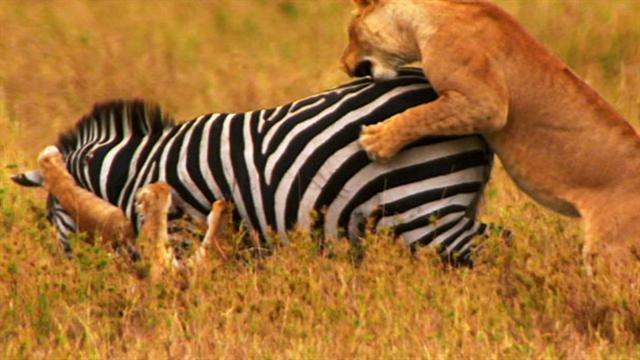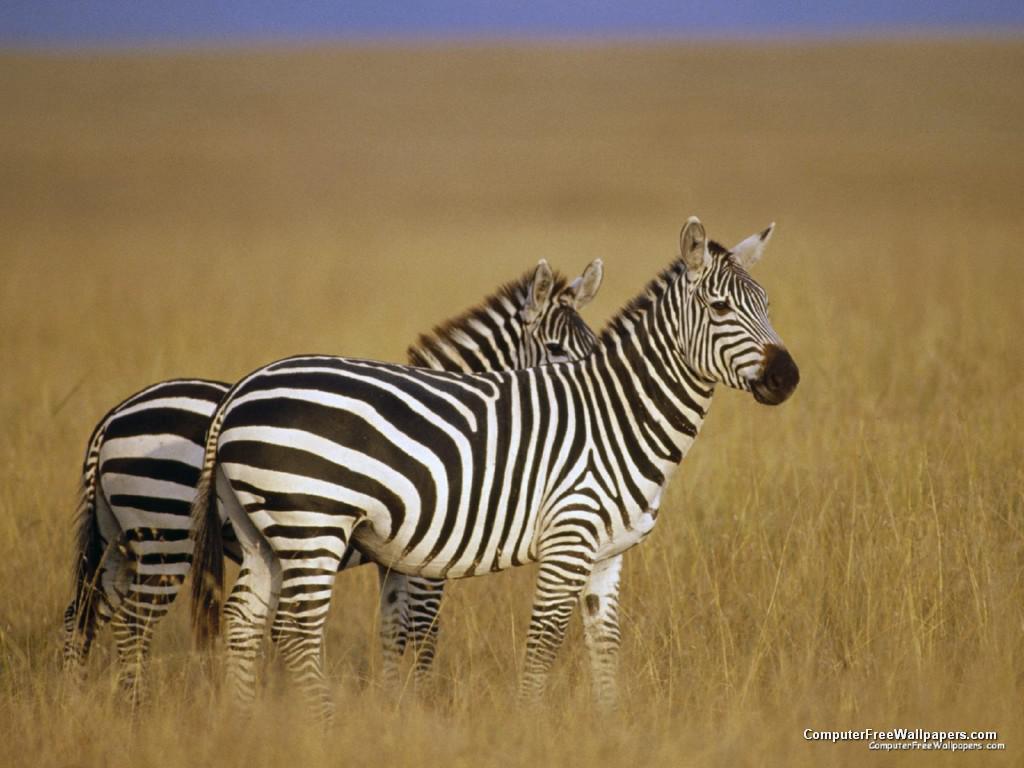The first image is the image on the left, the second image is the image on the right. Considering the images on both sides, is "There are animals fighting." valid? Answer yes or no. Yes. The first image is the image on the left, the second image is the image on the right. For the images displayed, is the sentence "A lion is pouncing on a zebra in one of the images." factually correct? Answer yes or no. Yes. 